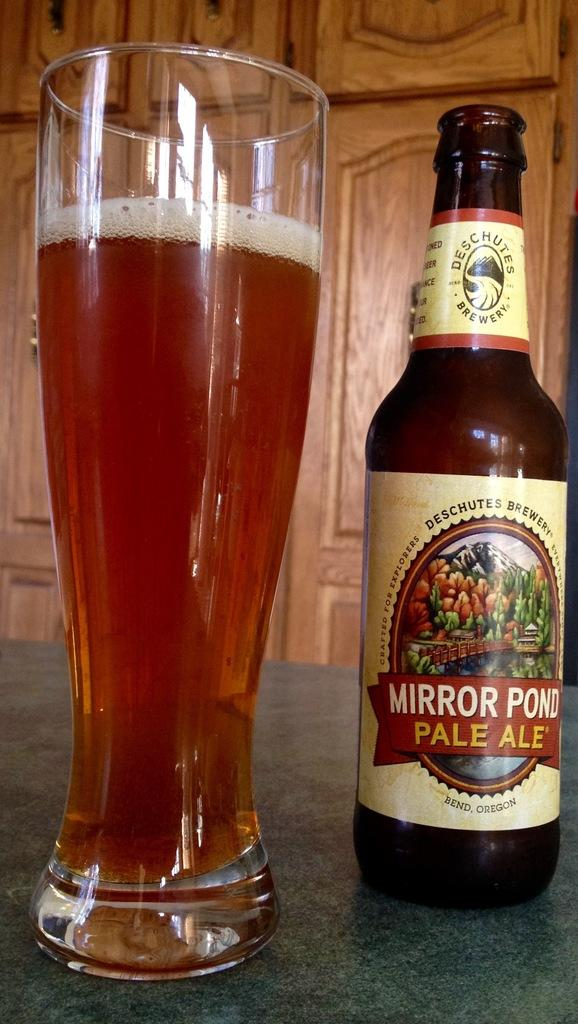<image>
Give a short and clear explanation of the subsequent image. Mirror Pond Pale Ale is crafted for explorers. 